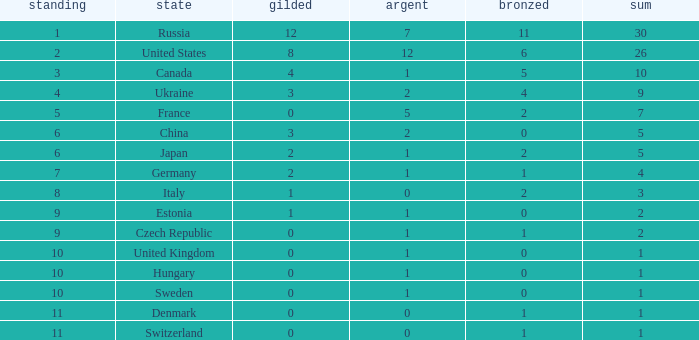Write the full table. {'header': ['standing', 'state', 'gilded', 'argent', 'bronzed', 'sum'], 'rows': [['1', 'Russia', '12', '7', '11', '30'], ['2', 'United States', '8', '12', '6', '26'], ['3', 'Canada', '4', '1', '5', '10'], ['4', 'Ukraine', '3', '2', '4', '9'], ['5', 'France', '0', '5', '2', '7'], ['6', 'China', '3', '2', '0', '5'], ['6', 'Japan', '2', '1', '2', '5'], ['7', 'Germany', '2', '1', '1', '4'], ['8', 'Italy', '1', '0', '2', '3'], ['9', 'Estonia', '1', '1', '0', '2'], ['9', 'Czech Republic', '0', '1', '1', '2'], ['10', 'United Kingdom', '0', '1', '0', '1'], ['10', 'Hungary', '0', '1', '0', '1'], ['10', 'Sweden', '0', '1', '0', '1'], ['11', 'Denmark', '0', '0', '1', '1'], ['11', 'Switzerland', '0', '0', '1', '1']]} Which silver has a Gold smaller than 12, a Rank smaller than 5, and a Bronze of 5? 1.0. 